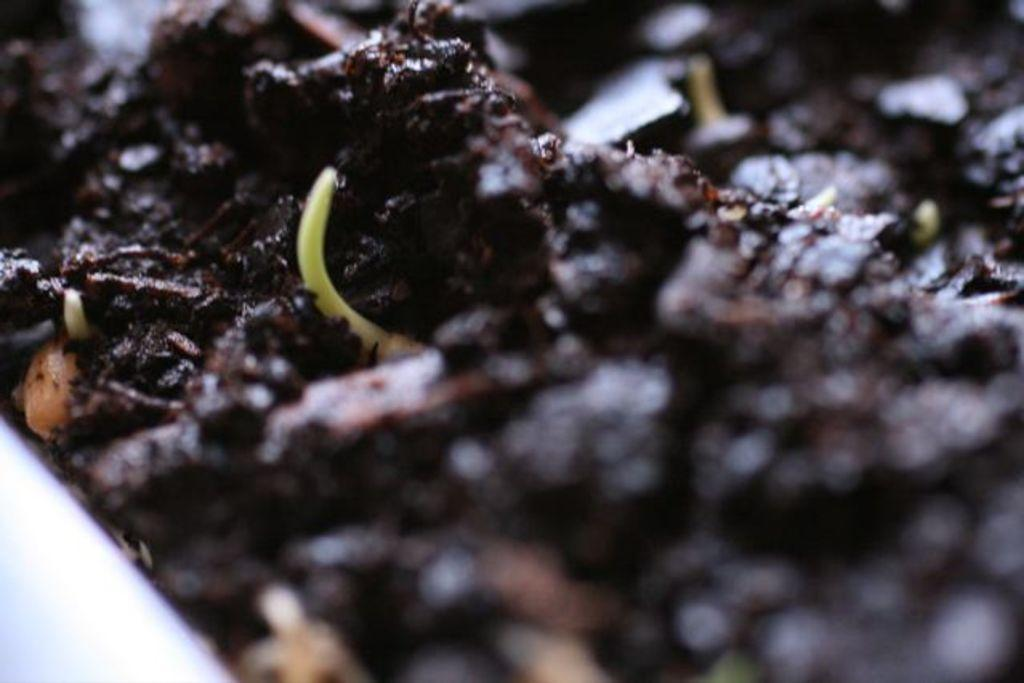What is present in the image that should not be there? There is garbage in the image. What type of education is being provided to the coal in the image? There is no coal or education present in the image; it only contains garbage. 